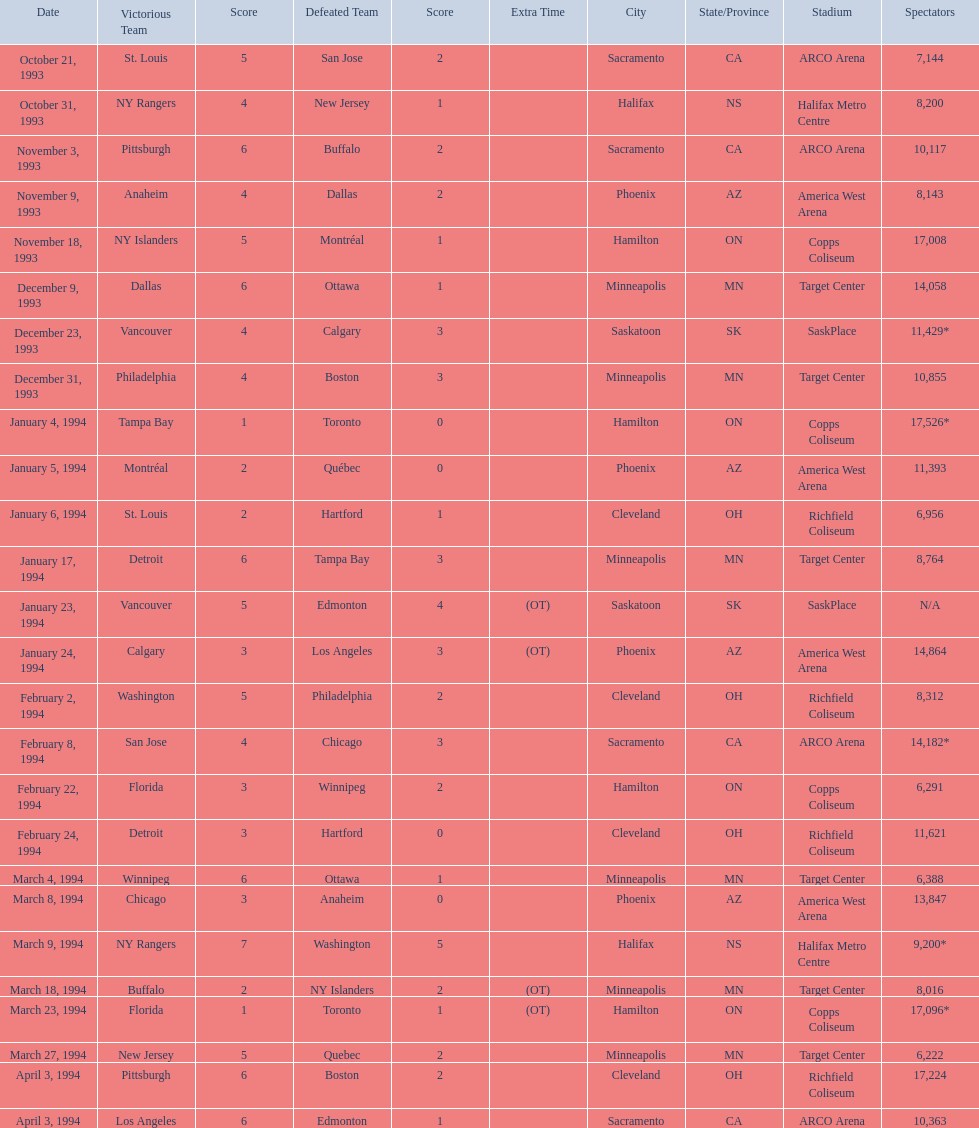What are the attendances of the 1993-94 nhl season? 7,144, 8,200, 10,117, 8,143, 17,008, 14,058, 11,429*, 10,855, 17,526*, 11,393, 6,956, 8,764, N/A, 14,864, 8,312, 14,182*, 6,291, 11,621, 6,388, 13,847, 9,200*, 8,016, 17,096*, 6,222, 17,224, 10,363. Which of these is the highest attendance? 17,526*. Which date did this attendance occur? January 4, 1994. 